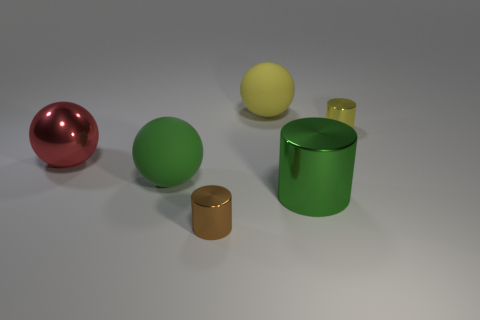Add 2 big cyan cylinders. How many objects exist? 8 Subtract all yellow metallic objects. Subtract all large green matte objects. How many objects are left? 4 Add 6 big red shiny balls. How many big red shiny balls are left? 7 Add 1 small green blocks. How many small green blocks exist? 1 Subtract 0 yellow cubes. How many objects are left? 6 